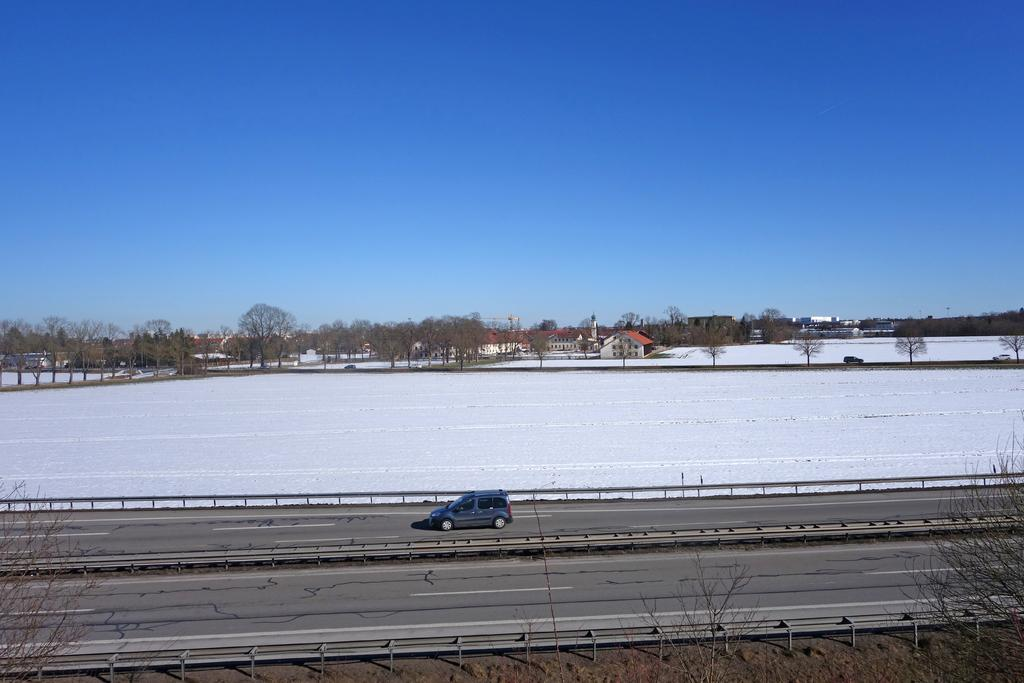What type of vehicle is in the image? There is a gray car in the image. What can be seen in the background of the image? The background of the image includes snow in white color, houses in white color, and trees in green color. What color is the sky in the image? The sky is in blue color. Can you tell me how many firemen are standing next to the car in the image? There are no firemen present in the image; it only features a gray car and the background elements. What type of hand gesture is the driver of the car making in the image? There is no indication of the driver's hand gestures in the image, as only the car and the background are visible. 